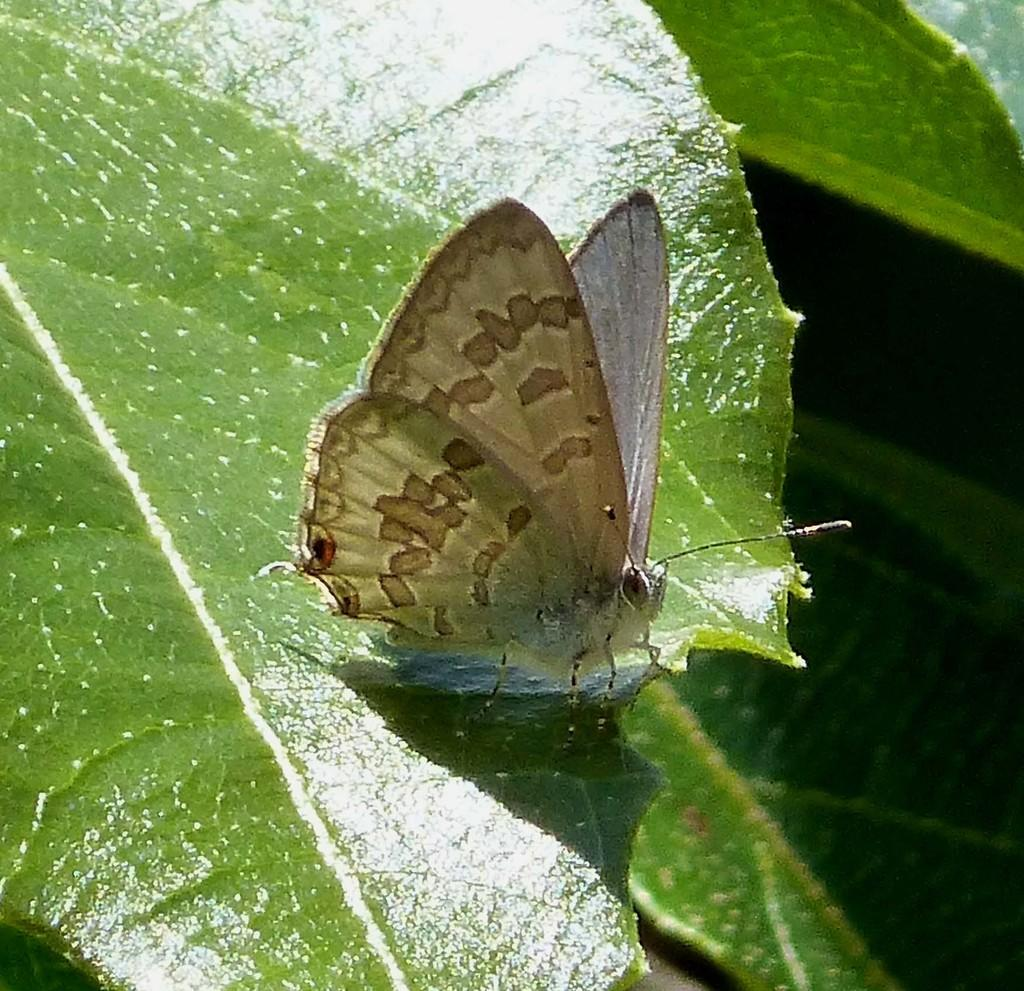What type of insect can be seen in the image? There is a butterfly in the image. What type of plant material is present in the image? There are leaves in the image. What type of cup is being used to hold the tomatoes in the image? There is no cup or tomatoes present in the image; it only features a butterfly and leaves. 